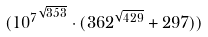Convert formula to latex. <formula><loc_0><loc_0><loc_500><loc_500>( { 1 0 ^ { 7 } } ^ { \sqrt { 3 5 3 } } \cdot ( 3 6 2 ^ { \sqrt { 4 2 9 } } + 2 9 7 ) )</formula> 